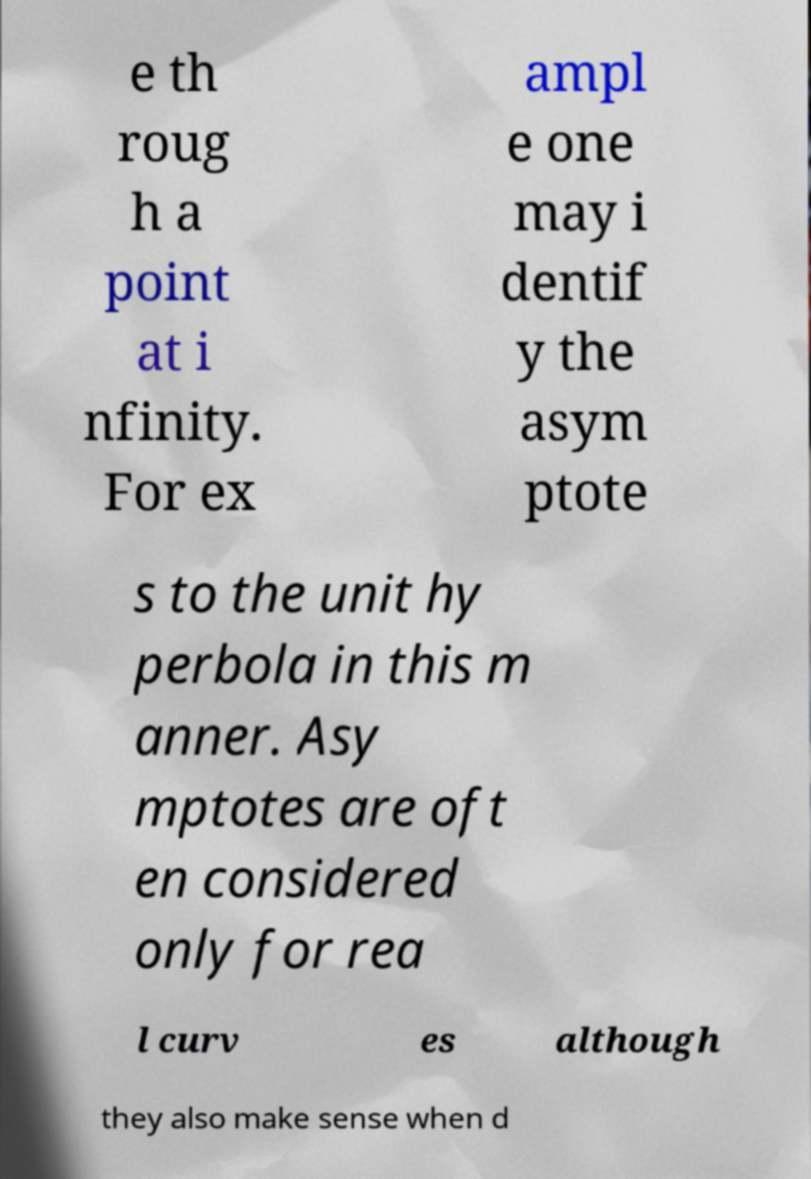Can you accurately transcribe the text from the provided image for me? e th roug h a point at i nfinity. For ex ampl e one may i dentif y the asym ptote s to the unit hy perbola in this m anner. Asy mptotes are oft en considered only for rea l curv es although they also make sense when d 